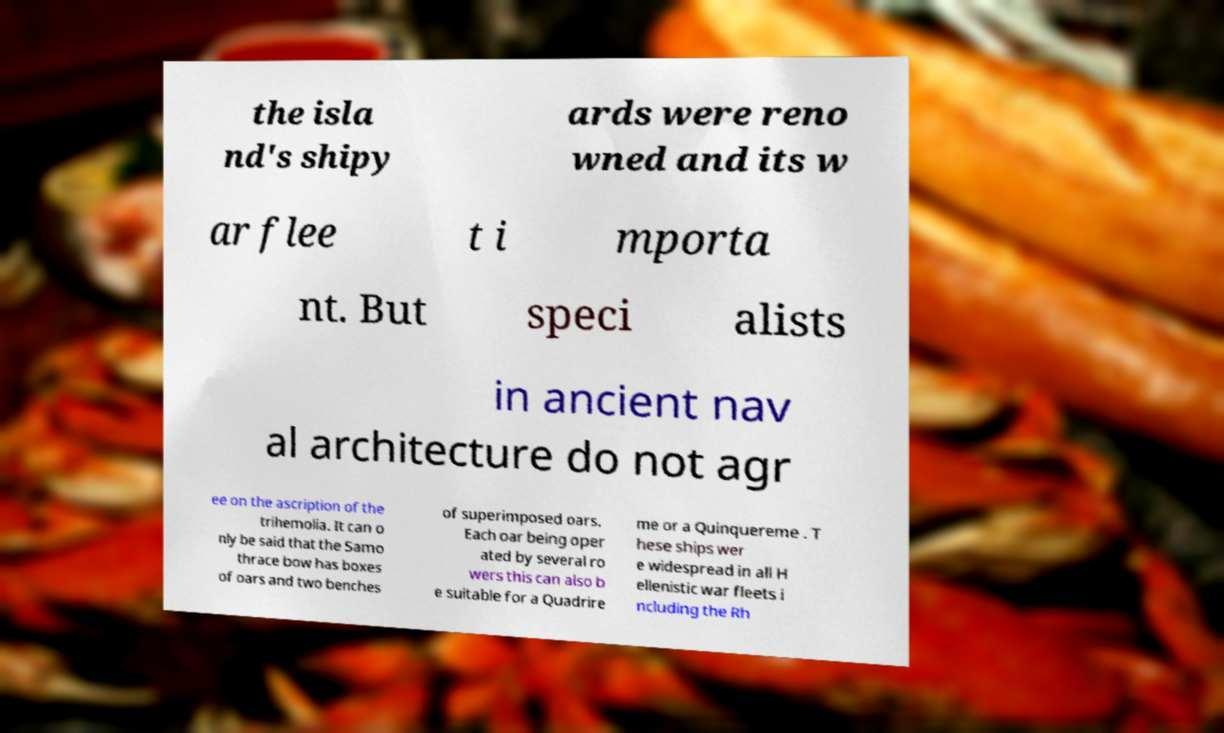Please read and relay the text visible in this image. What does it say? the isla nd's shipy ards were reno wned and its w ar flee t i mporta nt. But speci alists in ancient nav al architecture do not agr ee on the ascription of the trihemolia. It can o nly be said that the Samo thrace bow has boxes of oars and two benches of superimposed oars. Each oar being oper ated by several ro wers this can also b e suitable for a Quadrire me or a Quinquereme . T hese ships wer e widespread in all H ellenistic war fleets i ncluding the Rh 